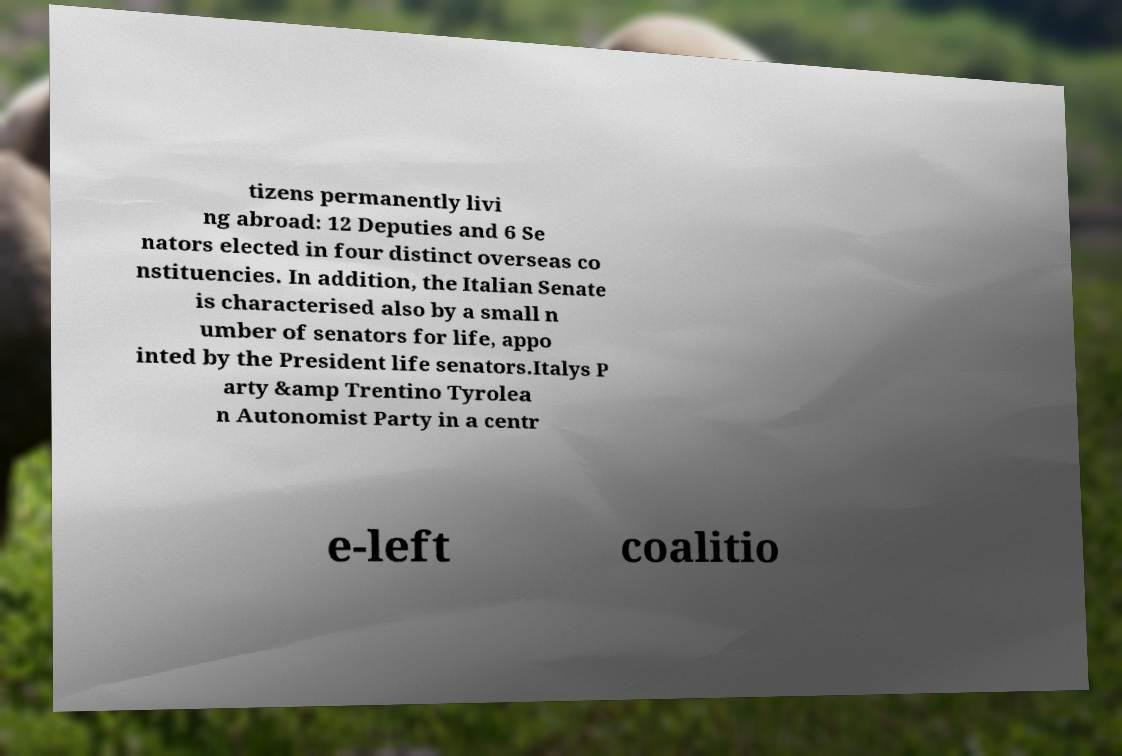For documentation purposes, I need the text within this image transcribed. Could you provide that? tizens permanently livi ng abroad: 12 Deputies and 6 Se nators elected in four distinct overseas co nstituencies. In addition, the Italian Senate is characterised also by a small n umber of senators for life, appo inted by the President life senators.Italys P arty &amp Trentino Tyrolea n Autonomist Party in a centr e-left coalitio 